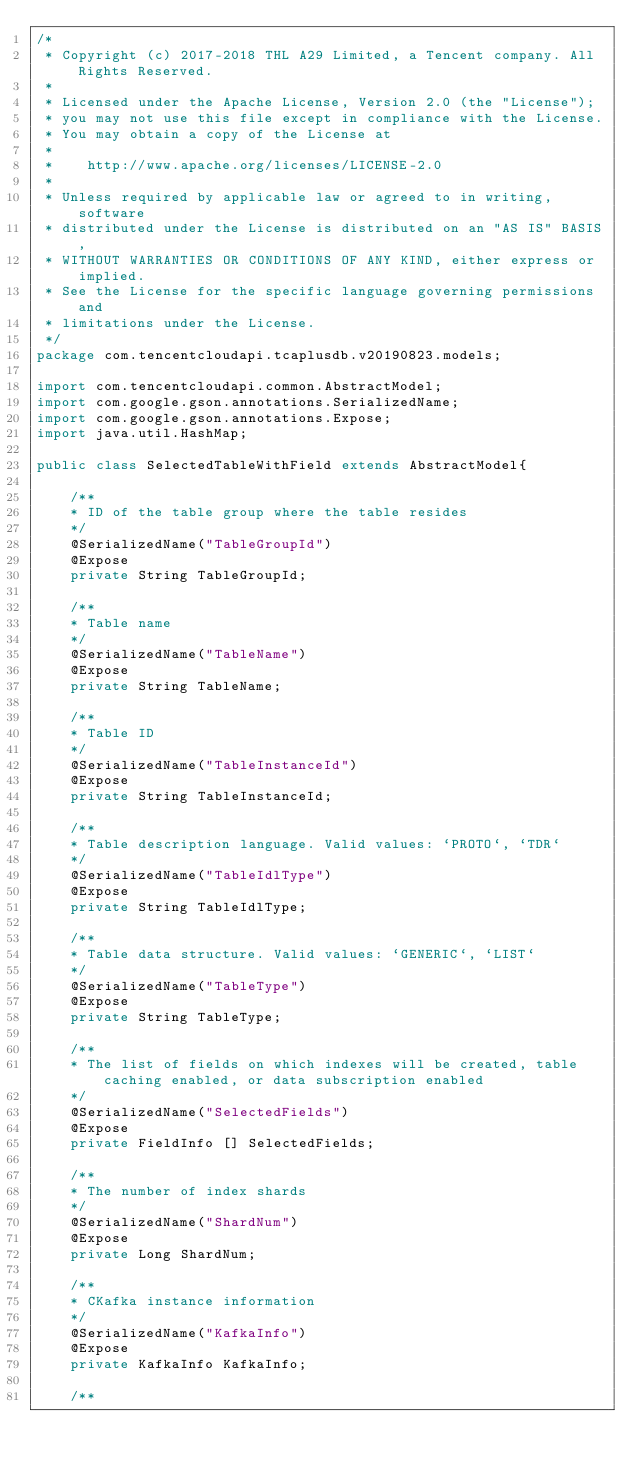<code> <loc_0><loc_0><loc_500><loc_500><_Java_>/*
 * Copyright (c) 2017-2018 THL A29 Limited, a Tencent company. All Rights Reserved.
 *
 * Licensed under the Apache License, Version 2.0 (the "License");
 * you may not use this file except in compliance with the License.
 * You may obtain a copy of the License at
 *
 *    http://www.apache.org/licenses/LICENSE-2.0
 *
 * Unless required by applicable law or agreed to in writing, software
 * distributed under the License is distributed on an "AS IS" BASIS,
 * WITHOUT WARRANTIES OR CONDITIONS OF ANY KIND, either express or implied.
 * See the License for the specific language governing permissions and
 * limitations under the License.
 */
package com.tencentcloudapi.tcaplusdb.v20190823.models;

import com.tencentcloudapi.common.AbstractModel;
import com.google.gson.annotations.SerializedName;
import com.google.gson.annotations.Expose;
import java.util.HashMap;

public class SelectedTableWithField extends AbstractModel{

    /**
    * ID of the table group where the table resides
    */
    @SerializedName("TableGroupId")
    @Expose
    private String TableGroupId;

    /**
    * Table name
    */
    @SerializedName("TableName")
    @Expose
    private String TableName;

    /**
    * Table ID
    */
    @SerializedName("TableInstanceId")
    @Expose
    private String TableInstanceId;

    /**
    * Table description language. Valid values: `PROTO`, `TDR`
    */
    @SerializedName("TableIdlType")
    @Expose
    private String TableIdlType;

    /**
    * Table data structure. Valid values: `GENERIC`, `LIST`
    */
    @SerializedName("TableType")
    @Expose
    private String TableType;

    /**
    * The list of fields on which indexes will be created, table caching enabled, or data subscription enabled
    */
    @SerializedName("SelectedFields")
    @Expose
    private FieldInfo [] SelectedFields;

    /**
    * The number of index shards
    */
    @SerializedName("ShardNum")
    @Expose
    private Long ShardNum;

    /**
    * CKafka instance information
    */
    @SerializedName("KafkaInfo")
    @Expose
    private KafkaInfo KafkaInfo;

    /**</code> 